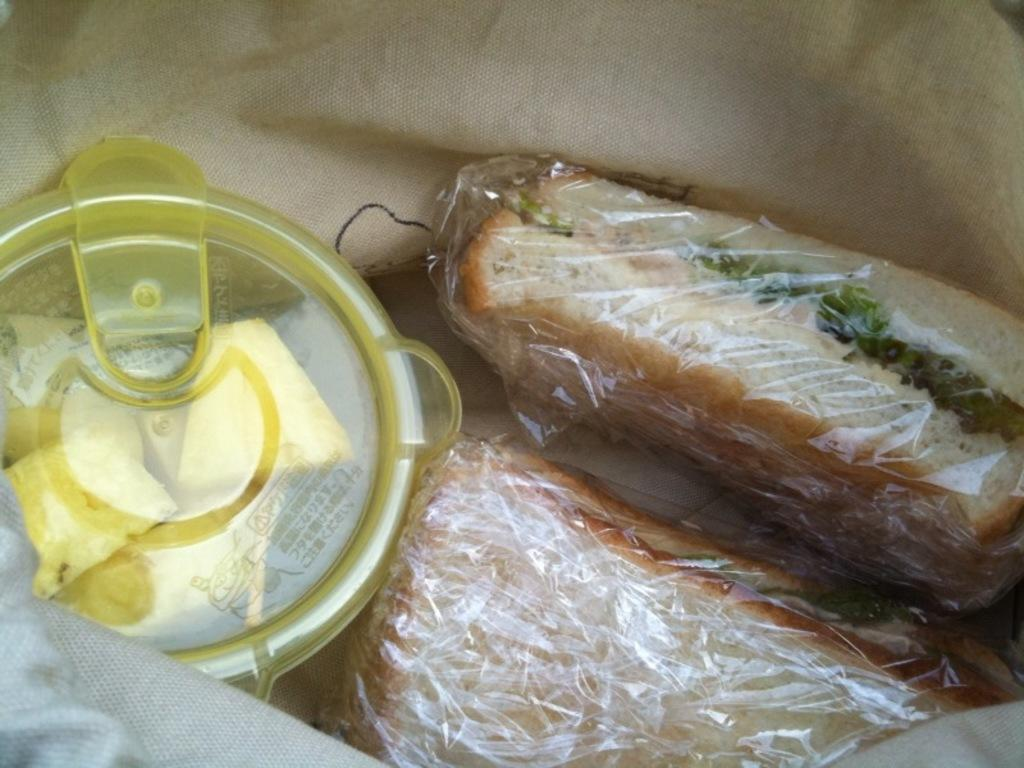What type of bag is in the image? There is a jute bag in the image. What is inside the jute bag? The jute bag contains breads. What other object can be seen in the image? There is a box in the image. What type of quiver is visible in the image? There is no quiver present in the image. 